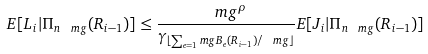<formula> <loc_0><loc_0><loc_500><loc_500>E [ L _ { i } | \Pi _ { n \ m g } ( R _ { i - 1 } ) ] \leq \frac { \ m g ^ { \rho } } { \gamma _ { \lfloor \sum _ { e = 1 } ^ { \ } m g B _ { e } ( R _ { i - 1 } ) / \ m g \rfloor } } E [ J _ { i } | \Pi _ { n \ m g } ( R _ { i - 1 } ) ]</formula> 